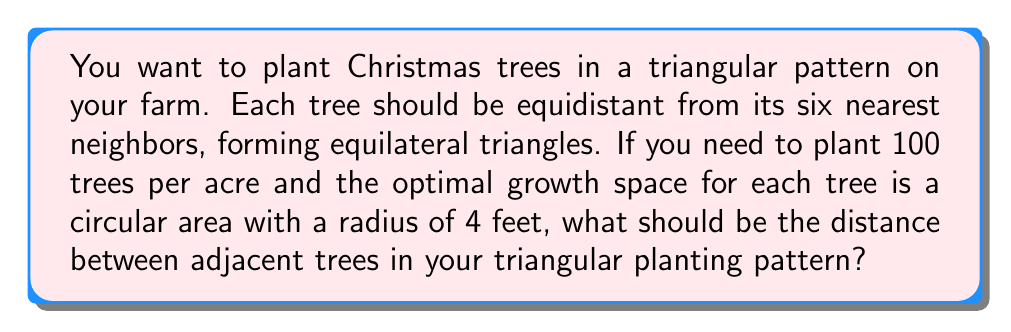Teach me how to tackle this problem. Let's approach this step-by-step:

1) First, we need to calculate the area each tree requires:
   Area per tree = $\frac{1 \text{ acre}}{100 \text{ trees}} = \frac{43560 \text{ sq ft}}{100} = 435.6 \text{ sq ft}$

2) In a triangular pattern, each tree occupies a hexagonal area. The area of a regular hexagon is:
   $A = \frac{3\sqrt{3}}{2}s^2$, where $s$ is the side length (distance between trees).

3) Equating this to our required area per tree:
   $435.6 = \frac{3\sqrt{3}}{2}s^2$

4) Solving for $s$:
   $s^2 = \frac{435.6 \cdot 2}{3\sqrt{3}} = 167.64$
   $s = \sqrt{167.64} \approx 12.95 \text{ ft}$

5) Now, we need to check if this satisfies the optimal growth space condition:
   In an equilateral triangle, the radius of the inscribed circle is:
   $r = \frac{s}{2\sqrt{3}} = \frac{12.95}{2\sqrt{3}} \approx 3.74 \text{ ft}$

6) This is slightly less than the optimal 4 ft radius, so we should increase our spacing.

7) If we use 4 ft as the radius of the inscribed circle:
   $s = 4 \cdot 2\sqrt{3} \approx 13.86 \text{ ft}$

8) This new spacing results in fewer trees per acre, but ensures optimal growth space:
   Trees per acre = $\frac{43560}{\frac{3\sqrt{3}}{2}(13.86)^2} \approx 87$

[asy]
unitsize(10);
pair A = (0,0), B = (1,0), C = (0.5, 0.866);
draw(A--B--C--cycle);
draw(circle(A, 0.577), dashed);
draw(circle(B, 0.577), dashed);
draw(circle(C, 0.577), dashed);
label("13.86 ft", (A+B)/2, S);
dot(A); dot(B); dot(C);
label("Tree", A, SW);
label("Tree", B, SE);
label("Tree", C, N);
[/asy]
Answer: 13.86 ft 